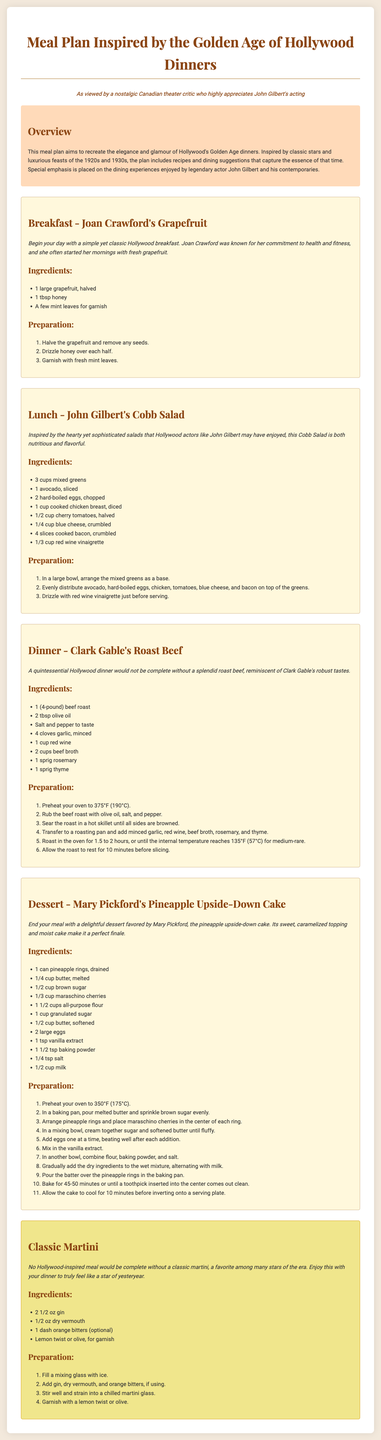What is the title of the meal plan? The title of the meal plan is found in the header of the document.
Answer: Meal Plan Inspired by the Golden Age of Hollywood Dinners Who is the breakfast inspired by? The breakfast is inspired by a famous actress known for health and fitness.
Answer: Joan Crawford What main ingredient is used in Clark Gable's roast beef? The primary ingredient for this dish is mentioned in the meal description and ingredients list.
Answer: Beef roast How many eggs are used in John Gilbert's Cobb Salad? The number of hard-boiled eggs required is specified in the ingredients list.
Answer: 2 What type of drink is suggested with the meal plan? The drink type is indicated under the drink section and associates with Hollywood glamor.
Answer: Classic Martini What flavoring is optional for the classic martini? The optional flavoring is mentioned in the drink preparation section.
Answer: Orange bitters What is the preparation time for Mary Pickford's Pineapple Upside-Down Cake? The baking time is noted in the preparation steps.
Answer: 45-50 minutes How many cups of mixed greens are needed for the lunch meal? The quantity is specified in the ingredients list for the Cobb Salad.
Answer: 3 cups 